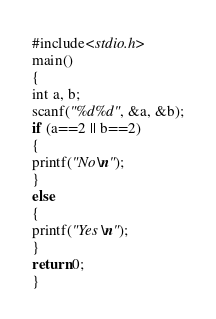Convert code to text. <code><loc_0><loc_0><loc_500><loc_500><_C_>#include<stdio.h>
main()
{
int a, b;
scanf("%d%d", &a, &b);
if (a==2 || b==2)
{
printf("No\n");
}
else
{
printf("Yes\n");
}
return 0;
}</code> 